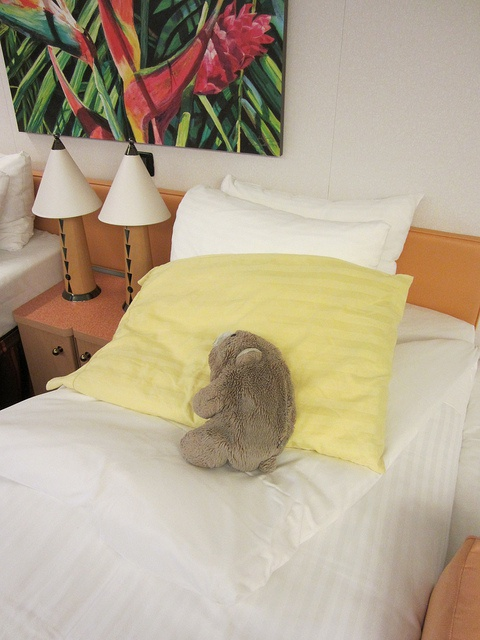Describe the objects in this image and their specific colors. I can see bed in brown, lightgray, tan, khaki, and darkgray tones and teddy bear in brown, gray, and tan tones in this image. 